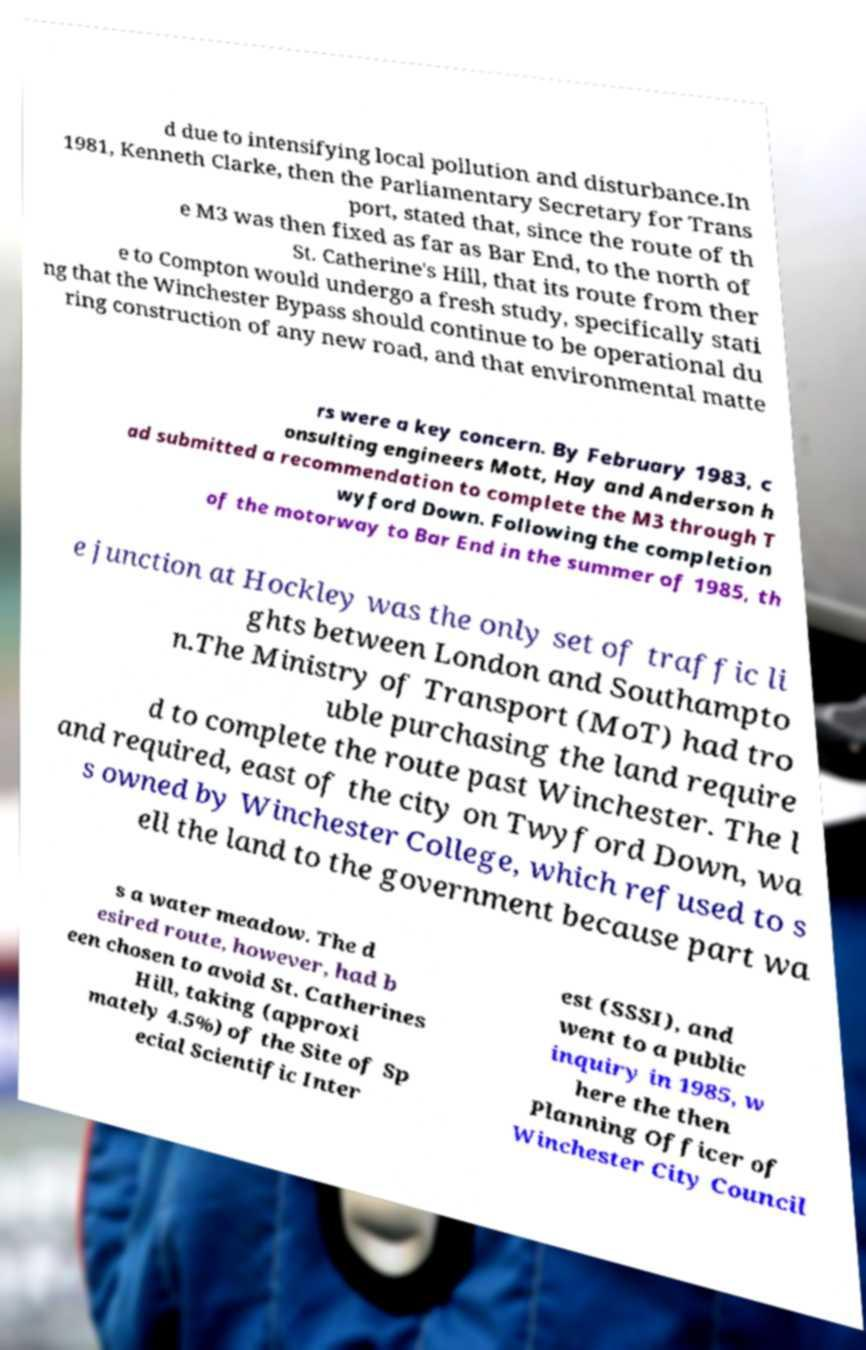Could you assist in decoding the text presented in this image and type it out clearly? d due to intensifying local pollution and disturbance.In 1981, Kenneth Clarke, then the Parliamentary Secretary for Trans port, stated that, since the route of th e M3 was then fixed as far as Bar End, to the north of St. Catherine's Hill, that its route from ther e to Compton would undergo a fresh study, specifically stati ng that the Winchester Bypass should continue to be operational du ring construction of any new road, and that environmental matte rs were a key concern. By February 1983, c onsulting engineers Mott, Hay and Anderson h ad submitted a recommendation to complete the M3 through T wyford Down. Following the completion of the motorway to Bar End in the summer of 1985, th e junction at Hockley was the only set of traffic li ghts between London and Southampto n.The Ministry of Transport (MoT) had tro uble purchasing the land require d to complete the route past Winchester. The l and required, east of the city on Twyford Down, wa s owned by Winchester College, which refused to s ell the land to the government because part wa s a water meadow. The d esired route, however, had b een chosen to avoid St. Catherines Hill, taking (approxi mately 4.5%) of the Site of Sp ecial Scientific Inter est (SSSI), and went to a public inquiry in 1985, w here the then Planning Officer of Winchester City Council 